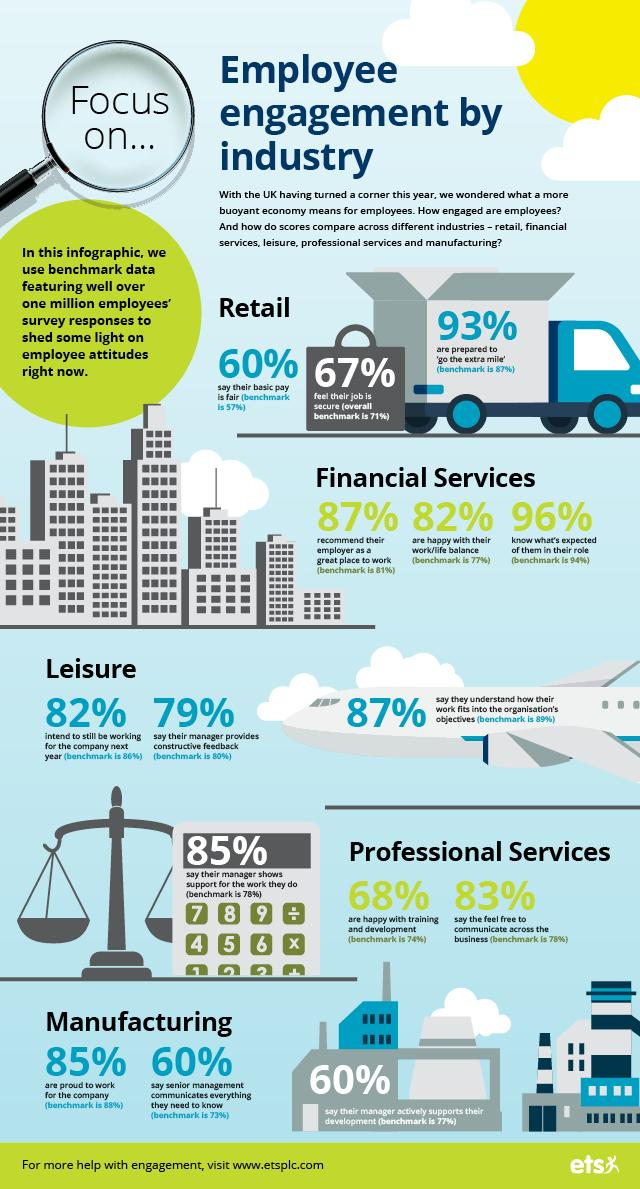List a handful of essential elements in this visual. According to the survey, 13% of UK employees in financial services do not recommend their employer as a great place to work. According to a recent survey, a significant 85% of UK employees in the manufacturing industry expressed pride in working for their company. According to the survey, 96% of UK employees in financial services reported that they are aware of their expected responsibilities in their roles. According to a recent survey, 33% of UK employees in retail services feel that their job is not secure. According to the survey, a large majority of UK employees in the financial services industry, 82%, are satisfied with their work-life balance. 